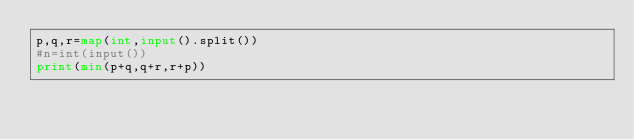Convert code to text. <code><loc_0><loc_0><loc_500><loc_500><_Python_>p,q,r=map(int,input().split())
#n=int(input())
print(min(p+q,q+r,r+p))</code> 